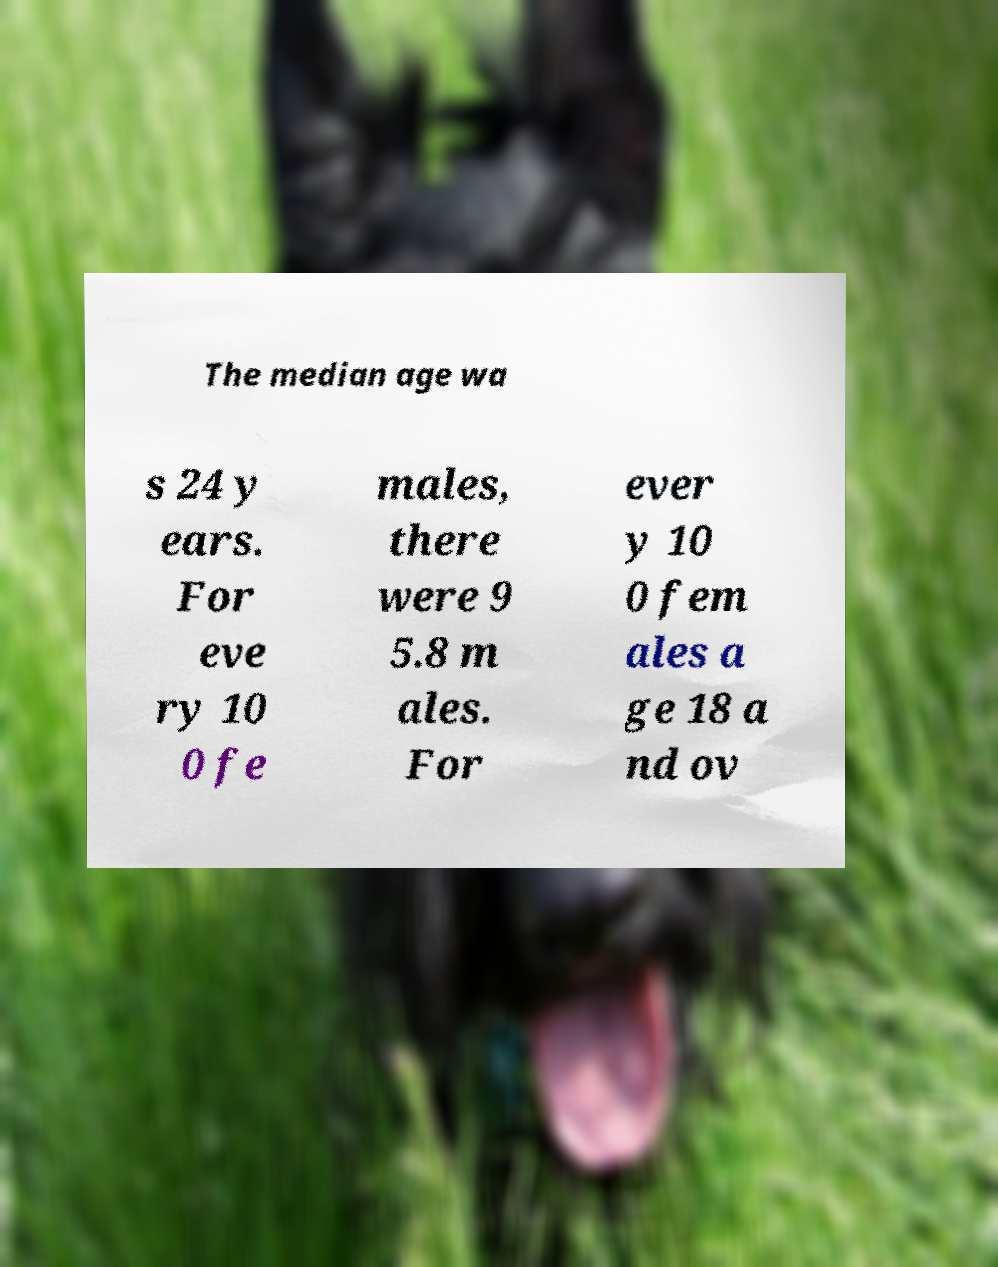Can you accurately transcribe the text from the provided image for me? The median age wa s 24 y ears. For eve ry 10 0 fe males, there were 9 5.8 m ales. For ever y 10 0 fem ales a ge 18 a nd ov 